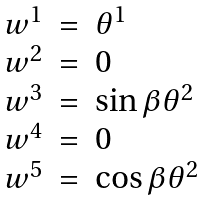<formula> <loc_0><loc_0><loc_500><loc_500>\begin{array} { l c l } w ^ { 1 } & = & \theta ^ { 1 } \\ w ^ { 2 } & = & 0 \\ w ^ { 3 } & = & \sin \beta \theta ^ { 2 } \\ w ^ { 4 } & = & 0 \\ w ^ { 5 } & = & \cos \beta \theta ^ { 2 } \\ \end{array}</formula> 